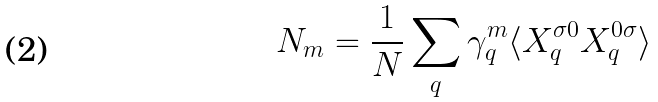<formula> <loc_0><loc_0><loc_500><loc_500>N _ { m } = \frac { 1 } { N } \sum _ { q } \gamma _ { q } ^ { m } \langle X _ { q } ^ { \sigma 0 } X _ { q } ^ { 0 \sigma } \rangle</formula> 